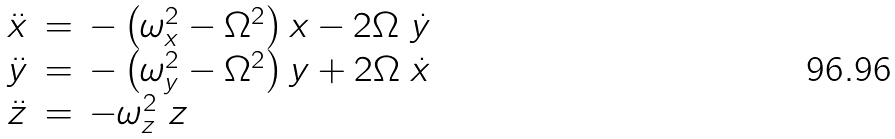Convert formula to latex. <formula><loc_0><loc_0><loc_500><loc_500>\begin{array} { l l l } \ddot { x } & = & - \left ( \omega _ { x } ^ { 2 } - \Omega ^ { 2 } \right ) x - 2 \Omega \ \dot { y } \\ \ddot { y } & = & - \left ( \omega _ { y } ^ { 2 } - \Omega ^ { 2 } \right ) y + 2 \Omega \ \dot { x } \\ \ddot { z } & = & - \omega _ { z } ^ { 2 } \ z \end{array}</formula> 